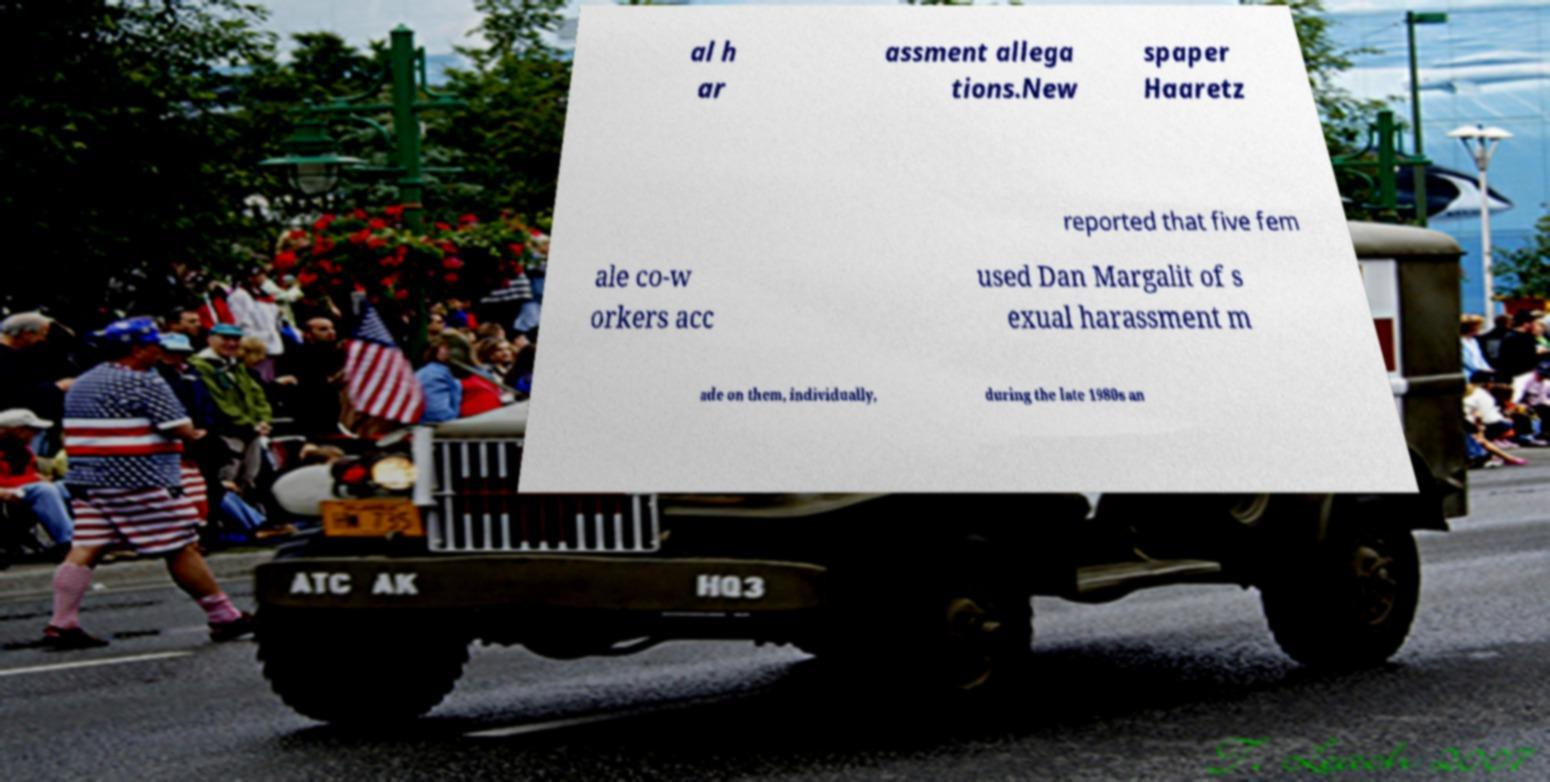Can you accurately transcribe the text from the provided image for me? al h ar assment allega tions.New spaper Haaretz reported that five fem ale co-w orkers acc used Dan Margalit of s exual harassment m ade on them, individually, during the late 1980s an 